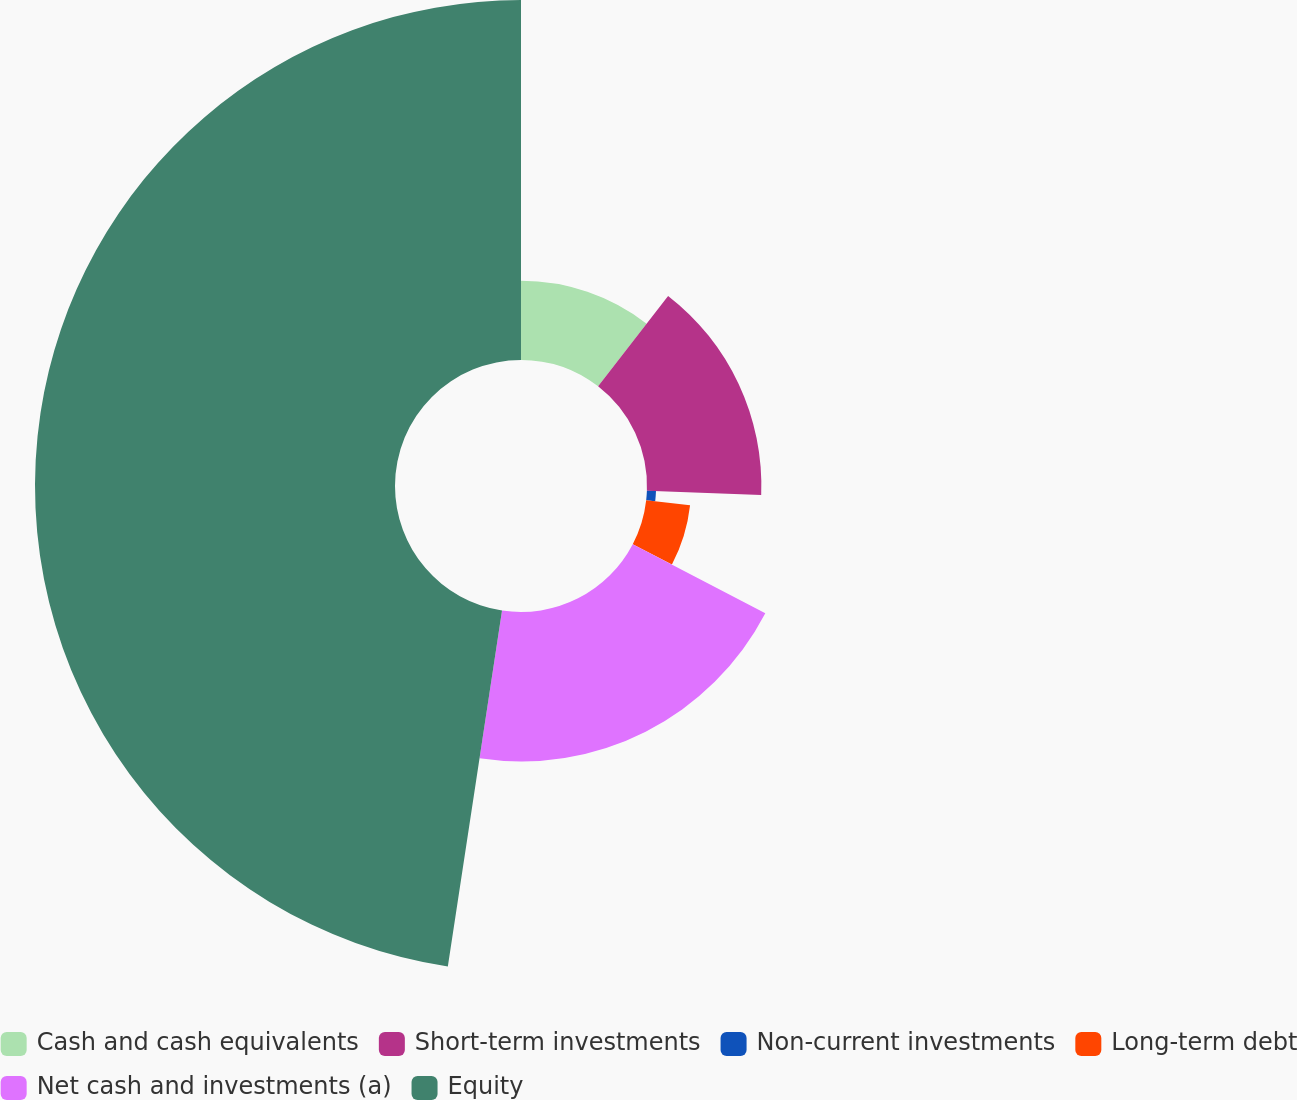<chart> <loc_0><loc_0><loc_500><loc_500><pie_chart><fcel>Cash and cash equivalents<fcel>Short-term investments<fcel>Non-current investments<fcel>Long-term debt<fcel>Net cash and investments (a)<fcel>Equity<nl><fcel>10.48%<fcel>15.12%<fcel>1.2%<fcel>5.84%<fcel>19.76%<fcel>47.59%<nl></chart> 